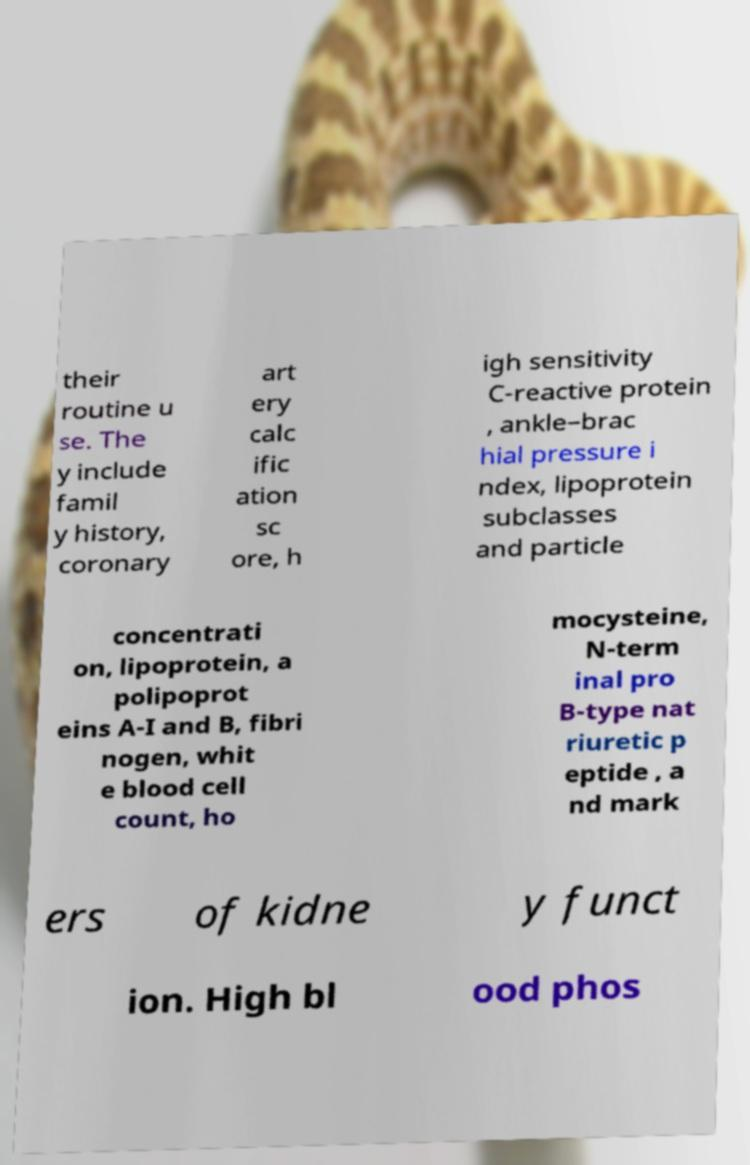Could you extract and type out the text from this image? their routine u se. The y include famil y history, coronary art ery calc ific ation sc ore, h igh sensitivity C-reactive protein , ankle–brac hial pressure i ndex, lipoprotein subclasses and particle concentrati on, lipoprotein, a polipoprot eins A-I and B, fibri nogen, whit e blood cell count, ho mocysteine, N-term inal pro B-type nat riuretic p eptide , a nd mark ers of kidne y funct ion. High bl ood phos 